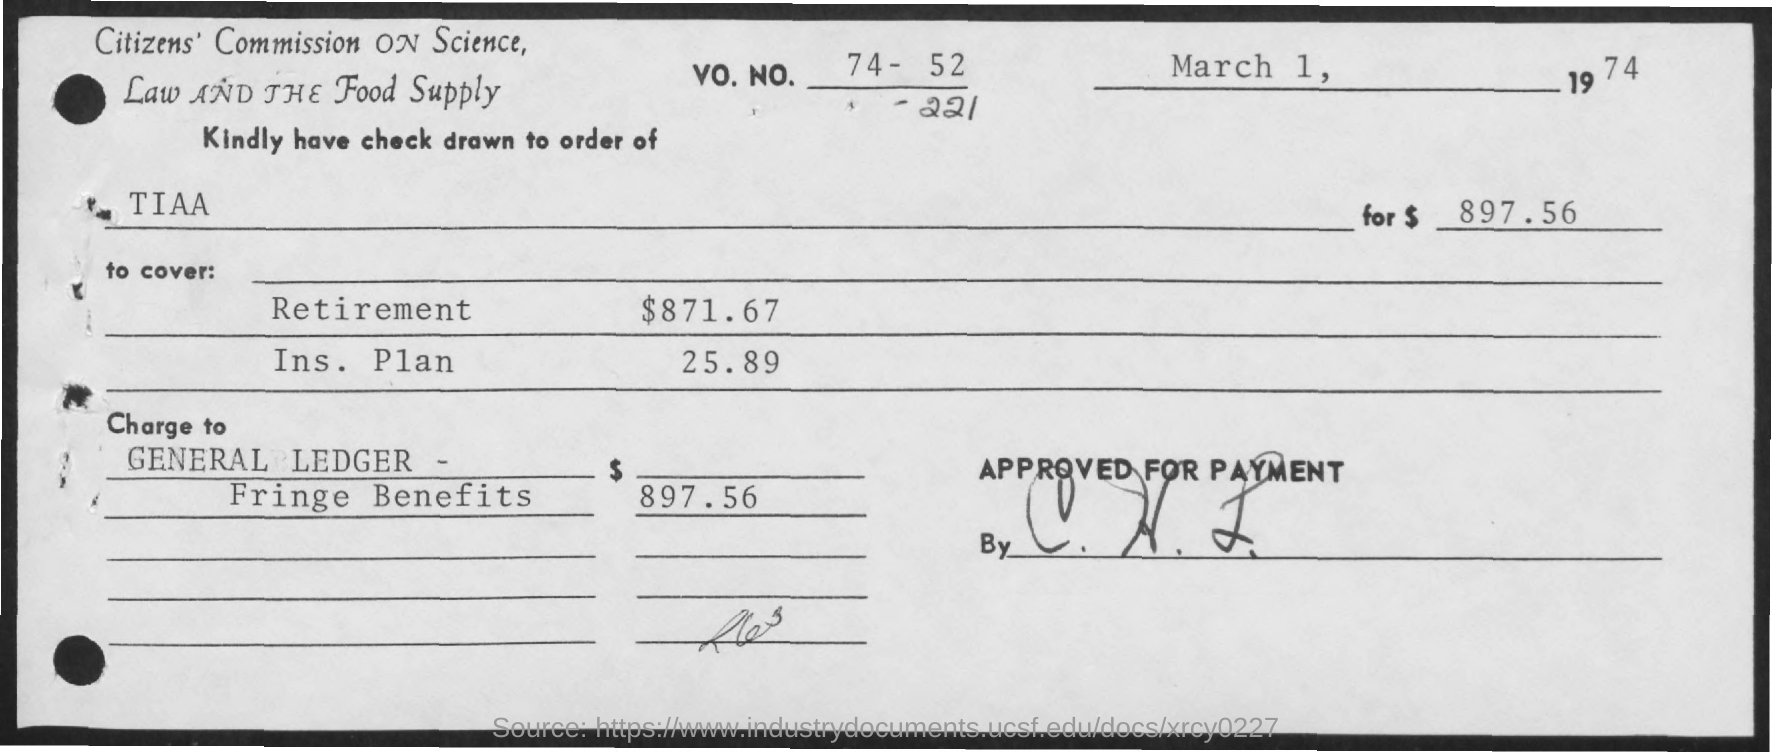Point out several critical features in this image. The amount required to cover for retirement is $871.67. The total amount mentioned is $897.56. Please review the attached check for the order of TIAA. The insurance plan requires a coverage amount of $25.89. 